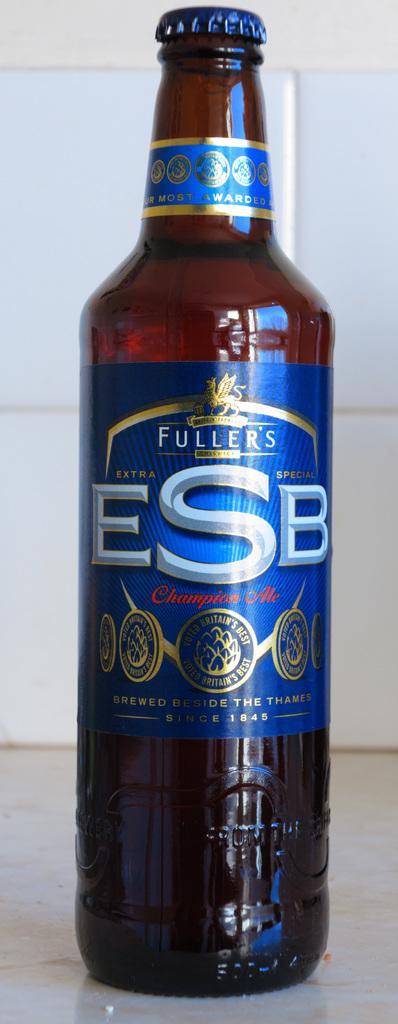Describe this image in one or two sentences. there is a brown glass bottle on which fuller's esb is written on the label. 